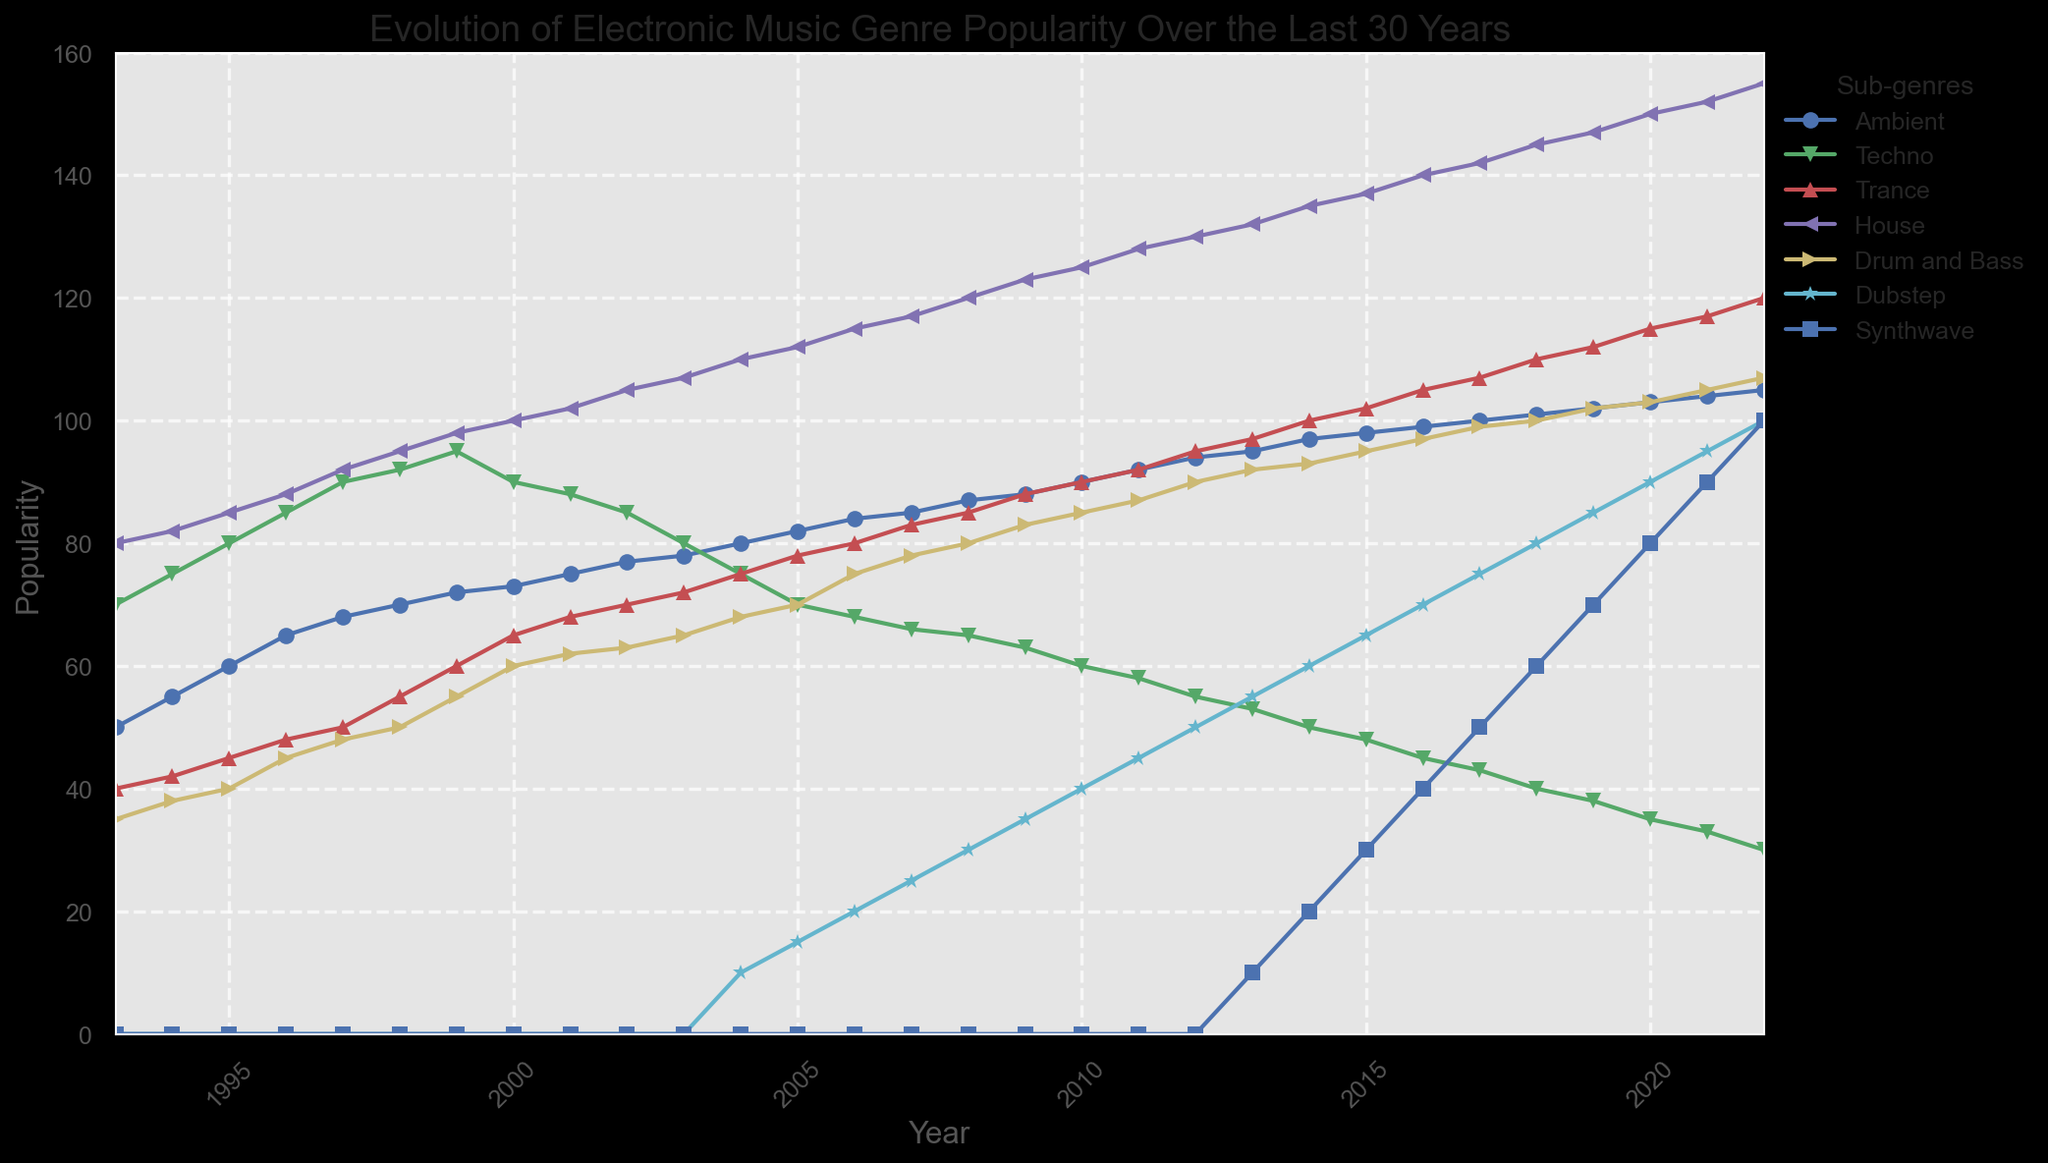Which electronic music genre has the steady highest popularity over the years? To determine which genre has consistently high popularity over the years, look at the lines representing each genre and see which one maintains the highest values throughout the timeline. "House" consistently stays at the top throughout all the years.
Answer: House In what year did Synthwave first appear in the data? Locate the starting point of the Synthwave line on the x-axis. Synthwave first appears with a positive value in 2013.
Answer: 2013 How did the popularity of Dubstep change from 2010 to 2014? Observe the Dubstep line from 2010 to 2014. In 2010, Dubstep has a value of 40. By 2014, it reaches a value of 60. Calculate the change: 60 - 40.
Answer: Increased by 20 Which genre saw the largest increase in popularity between 1993 and 2022? Compare the values for each genre in 1993 and 2022. House goes from 80 to 155, an increase of 75. Trance goes from 40 to 120, an increase of 80. Trance had the largest increase in popularity.
Answer: Trance Between Ambient and Techno, which genre had a higher popularity in 2013? Compare the values of Ambient and Techno for the year 2013. Ambient is at 95 and Techno is at 53. Ambient has a higher popularity.
Answer: Ambient Can you name the year when Drum and Bass reached its peak popularity according to the chart? Identify the highest point on the Drum and Bass line across all years. Drum and Bass reaches its peak in 2022 with a value of 107.
Answer: 2022 Which genre had the steepest decline after reaching its peak popularity? Look for sharp drops in the genre lines after their highest values. Techno peaks in 1999 at 95 and declines to 30 in 2022. It experienced the steepest decline.
Answer: Techno How long did it take for House to reach 100 in popularity? Trace the House line from 1993 when it started at 80 to the point it reaches 100 in 2000. It took 7 years.
Answer: 7 years What is the difference in popularity between Ambient and Dubstep in 2022? Find the values of Ambient and Dubstep in 2022. Ambient is at 105 and Dubstep is at 100. Calculate the difference: 105 - 100.
Answer: 5 